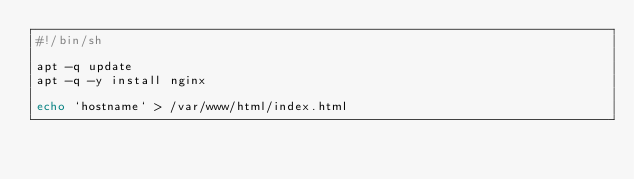Convert code to text. <code><loc_0><loc_0><loc_500><loc_500><_Bash_>#!/bin/sh

apt -q update
apt -q -y install nginx

echo `hostname` > /var/www/html/index.html

</code> 